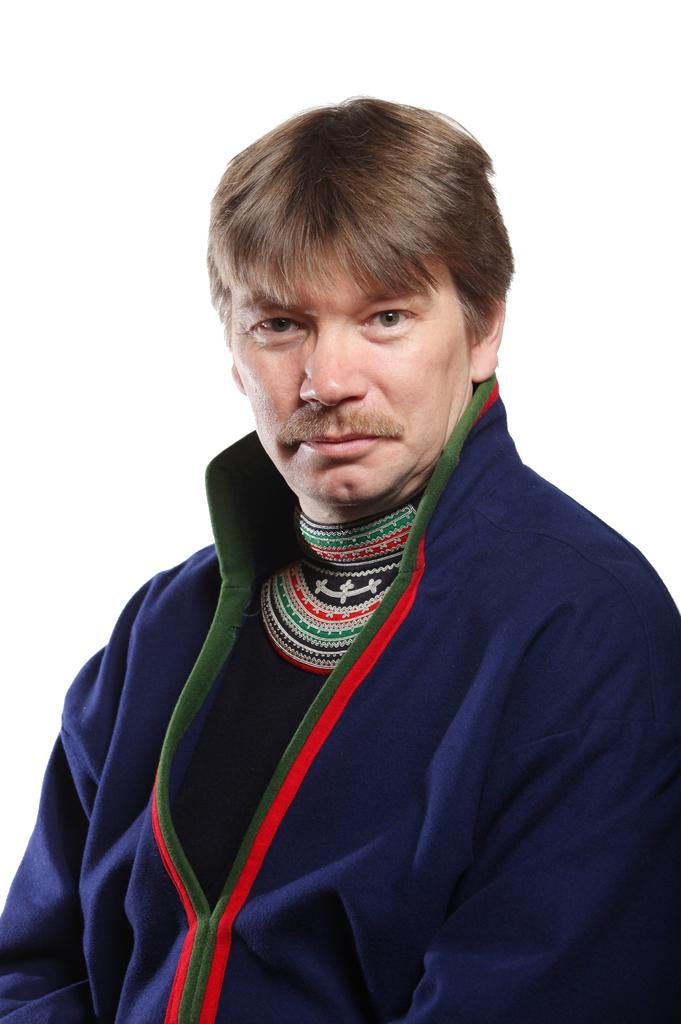What is the main subject of the image? There is a man standing in the center of the image. What is the man's facial expression? The man is smiling. Where can the man's smile be seen? The man's smile is visible on his face. What color is the jacket the man is wearing? The man is wearing a blue color jacket. What type of camera is the man holding in the image? There is no camera visible in the image; the man is not holding anything. 